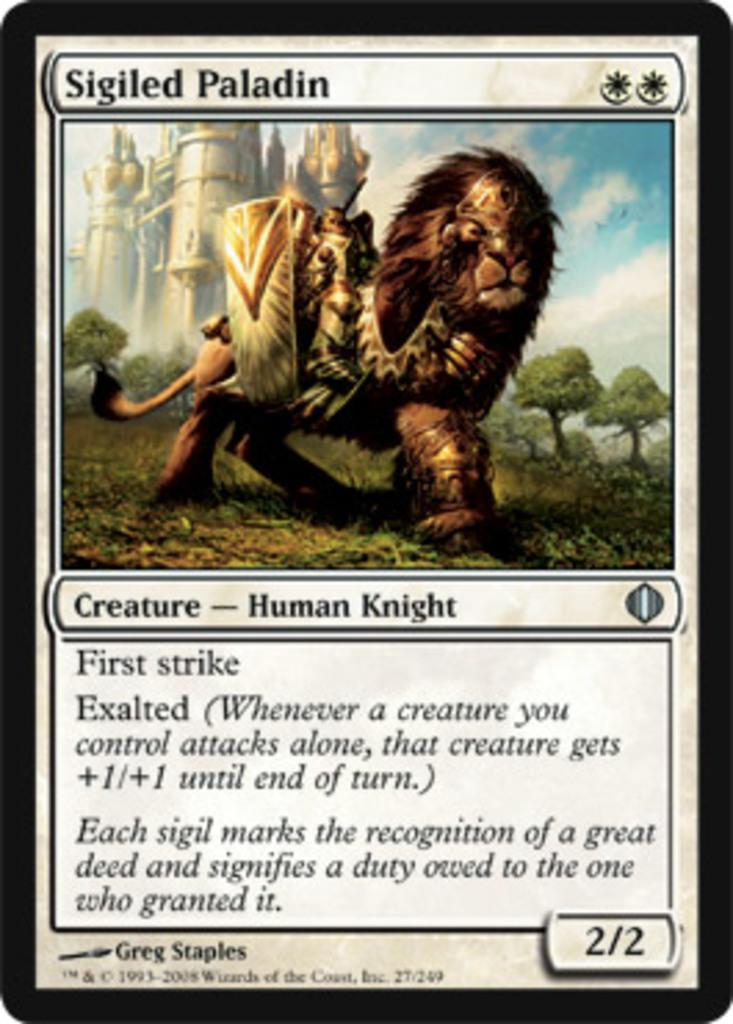What is the main subject of the poster in the image? The poster contains an image of a lion, a person, trees, a building, and the sky. What type of information is present on the poster? The poster contains some information. How many ducks are visible in the image? There are no ducks present in the image. What type of toy is being distributed in the image? There is no toy or distribution activity depicted in the image. 